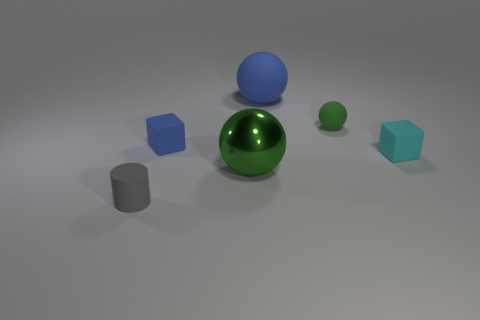Add 3 small gray metal balls. How many objects exist? 9 Subtract all cylinders. How many objects are left? 5 Subtract 1 gray cylinders. How many objects are left? 5 Subtract all big green metallic balls. Subtract all small blue blocks. How many objects are left? 4 Add 6 small gray matte cylinders. How many small gray matte cylinders are left? 7 Add 5 small blue matte blocks. How many small blue matte blocks exist? 6 